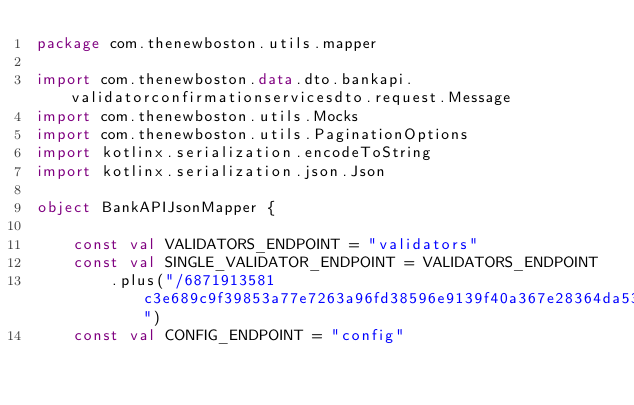Convert code to text. <code><loc_0><loc_0><loc_500><loc_500><_Kotlin_>package com.thenewboston.utils.mapper

import com.thenewboston.data.dto.bankapi.validatorconfirmationservicesdto.request.Message
import com.thenewboston.utils.Mocks
import com.thenewboston.utils.PaginationOptions
import kotlinx.serialization.encodeToString
import kotlinx.serialization.json.Json

object BankAPIJsonMapper {

    const val VALIDATORS_ENDPOINT = "validators"
    const val SINGLE_VALIDATOR_ENDPOINT = VALIDATORS_ENDPOINT
        .plus("/6871913581c3e689c9f39853a77e7263a96fd38596e9139f40a367e28364da53")
    const val CONFIG_ENDPOINT = "config"</code> 